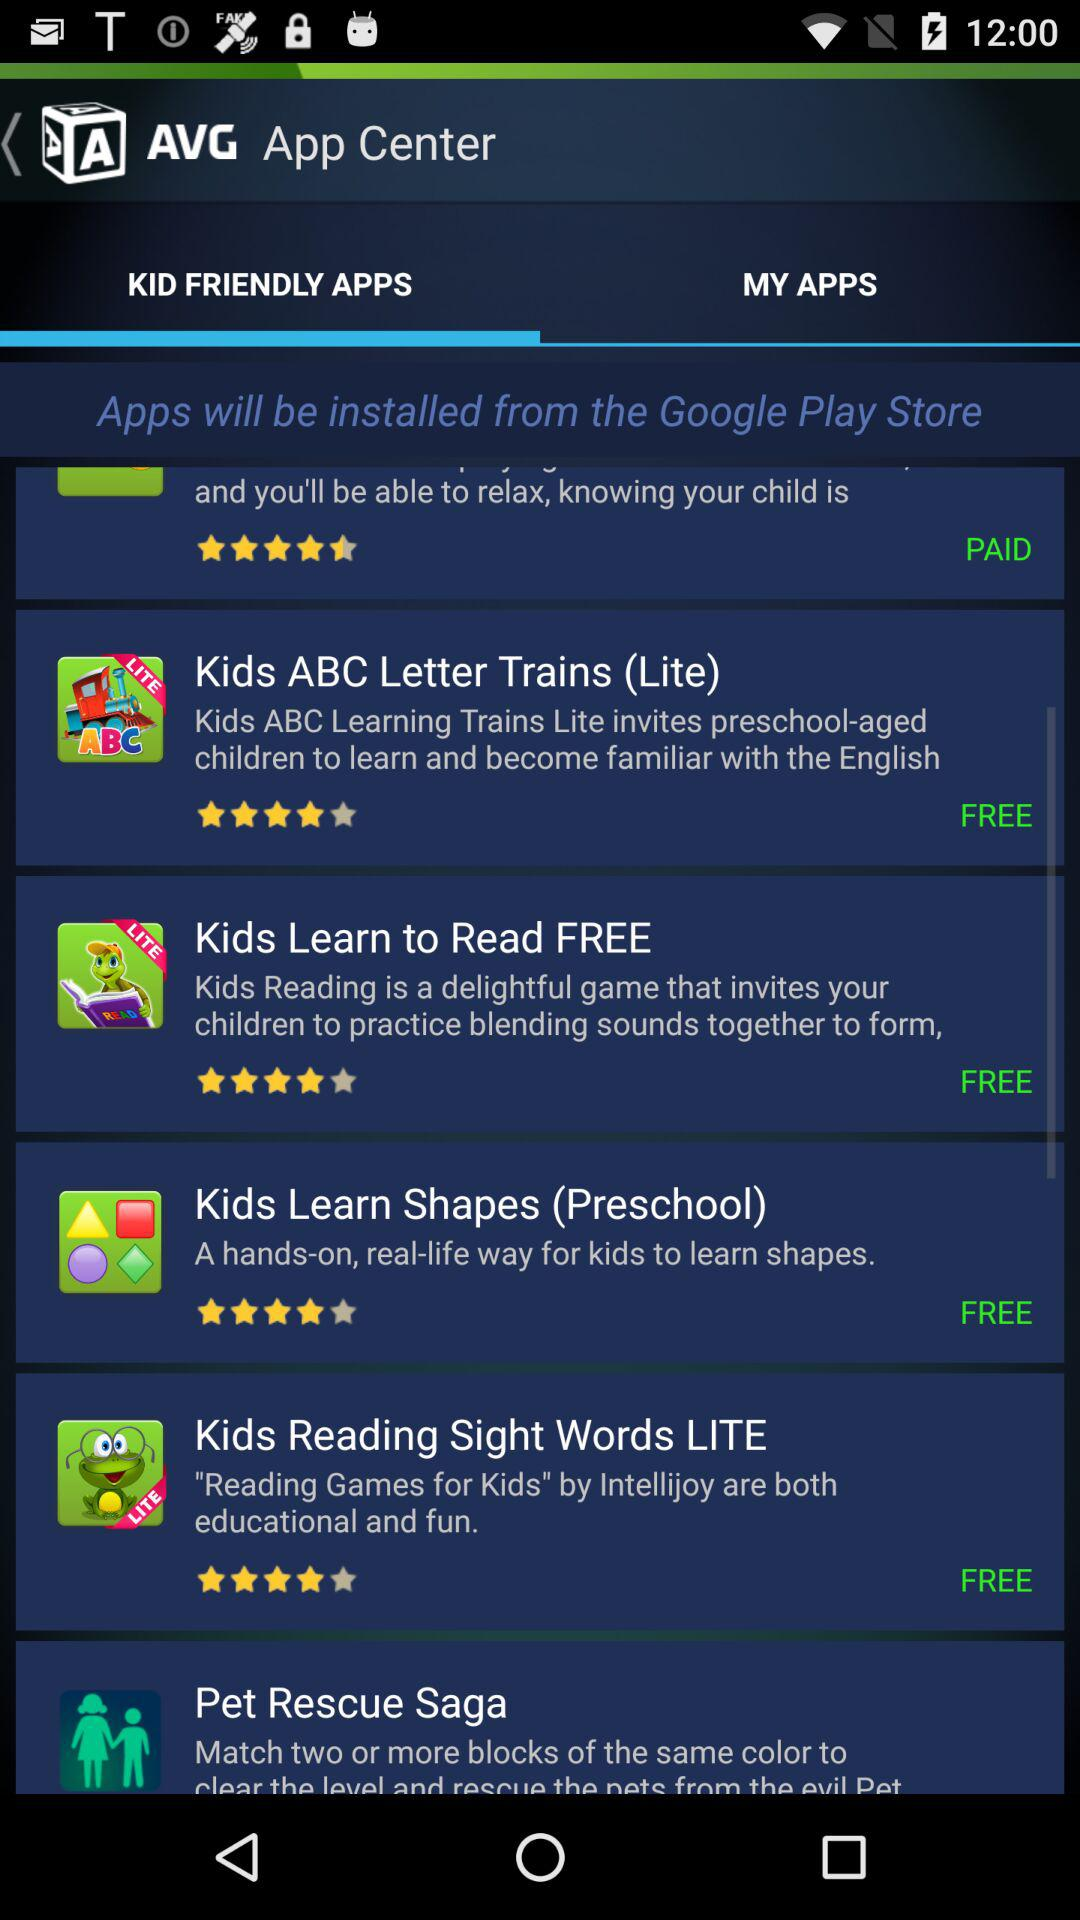What is the application name? The application name is "AVG App Center". 